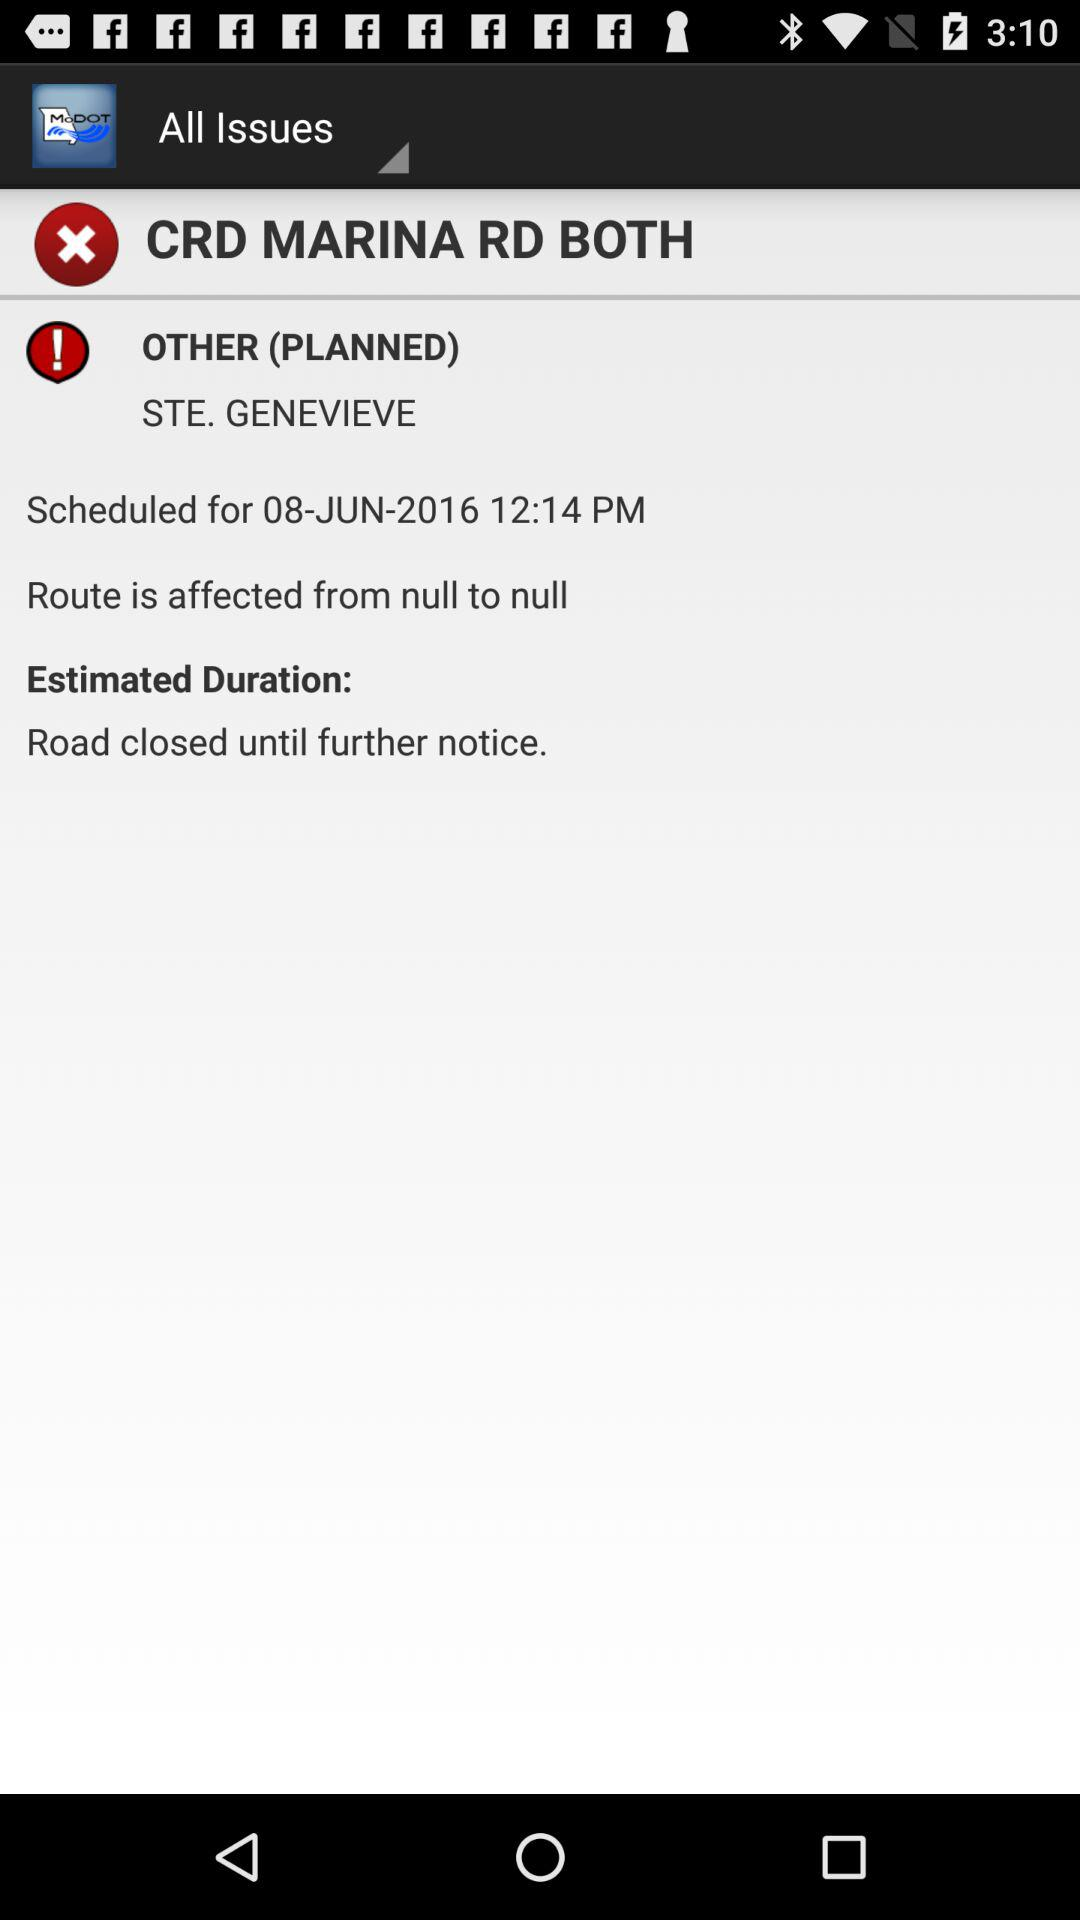What is the scheduled date and time? The date is June 8, 2016, and the time is 12:14 PM. 